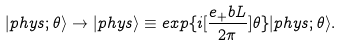<formula> <loc_0><loc_0><loc_500><loc_500>| p h y s ; \theta \rangle \rightarrow | p h y s \rangle \equiv e x p \{ i [ \frac { e _ { + } b L } { 2 \pi } ] \theta \} | p h y s ; \theta \rangle .</formula> 